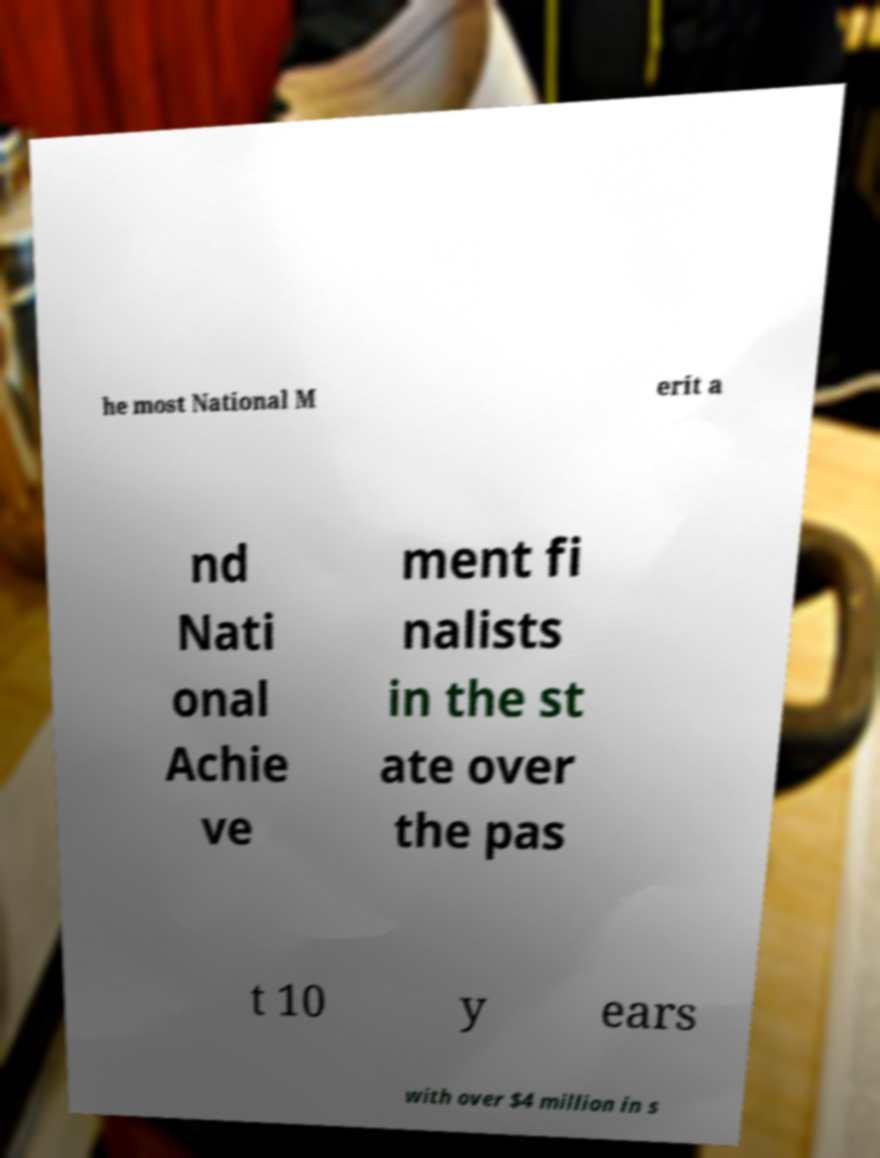What messages or text are displayed in this image? I need them in a readable, typed format. he most National M erit a nd Nati onal Achie ve ment fi nalists in the st ate over the pas t 10 y ears with over $4 million in s 